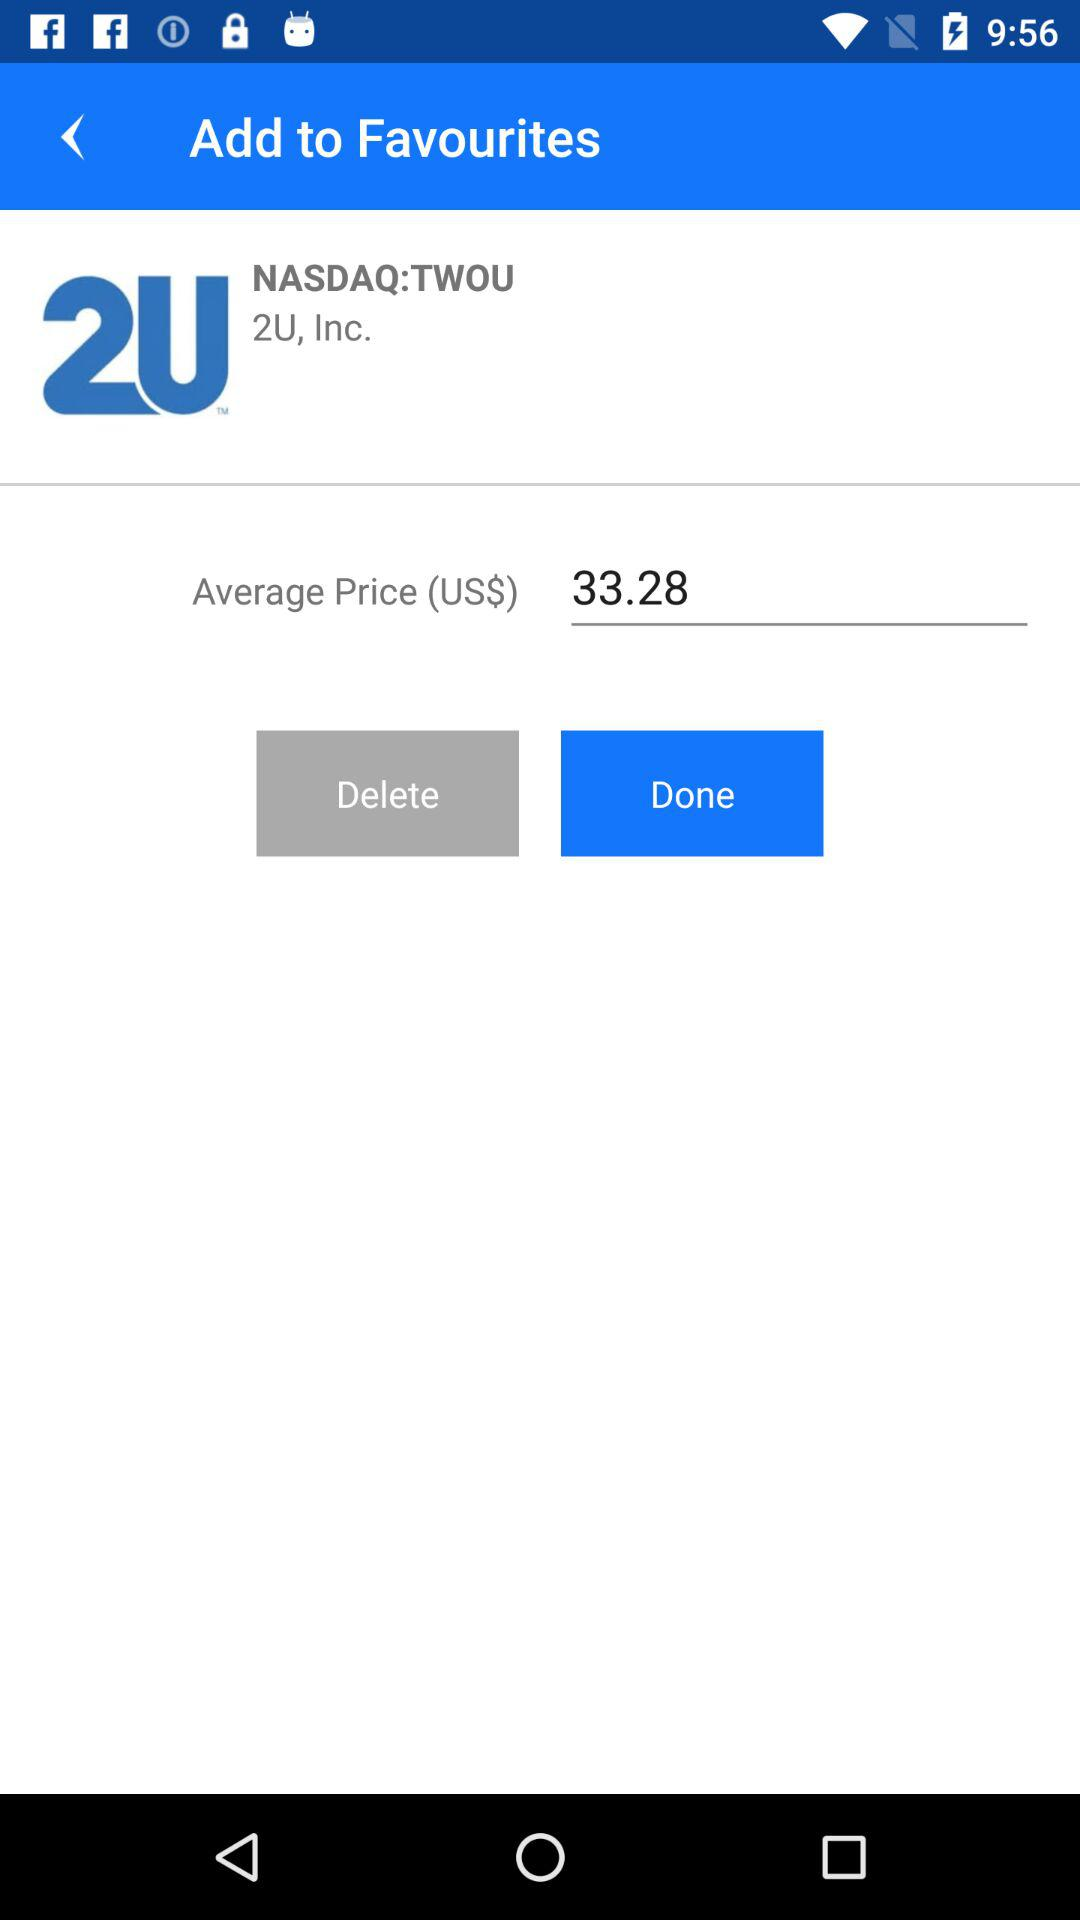What is the average price? The average price is 33.28 United States dollars. 